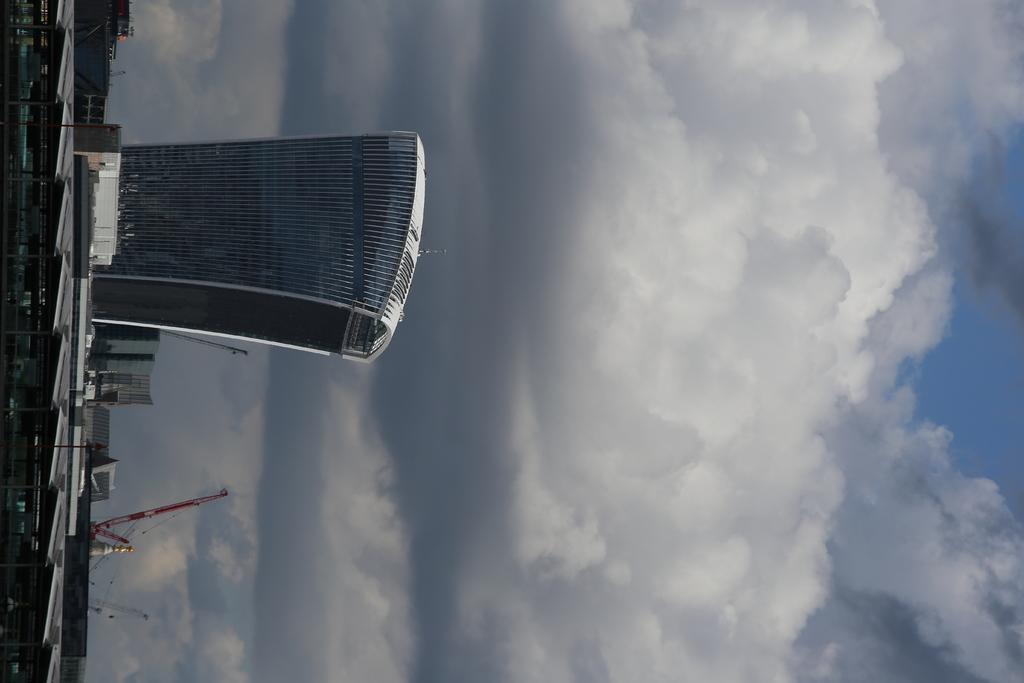Describe this image in one or two sentences. In the picture I can see buildings, poles and some other things. In the background I can see the sky. 